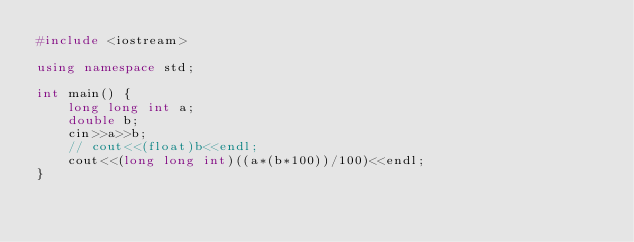<code> <loc_0><loc_0><loc_500><loc_500><_C++_>#include <iostream>

using namespace std;

int main() {
    long long int a;
    double b;
    cin>>a>>b;
    // cout<<(float)b<<endl;
    cout<<(long long int)((a*(b*100))/100)<<endl;
}</code> 